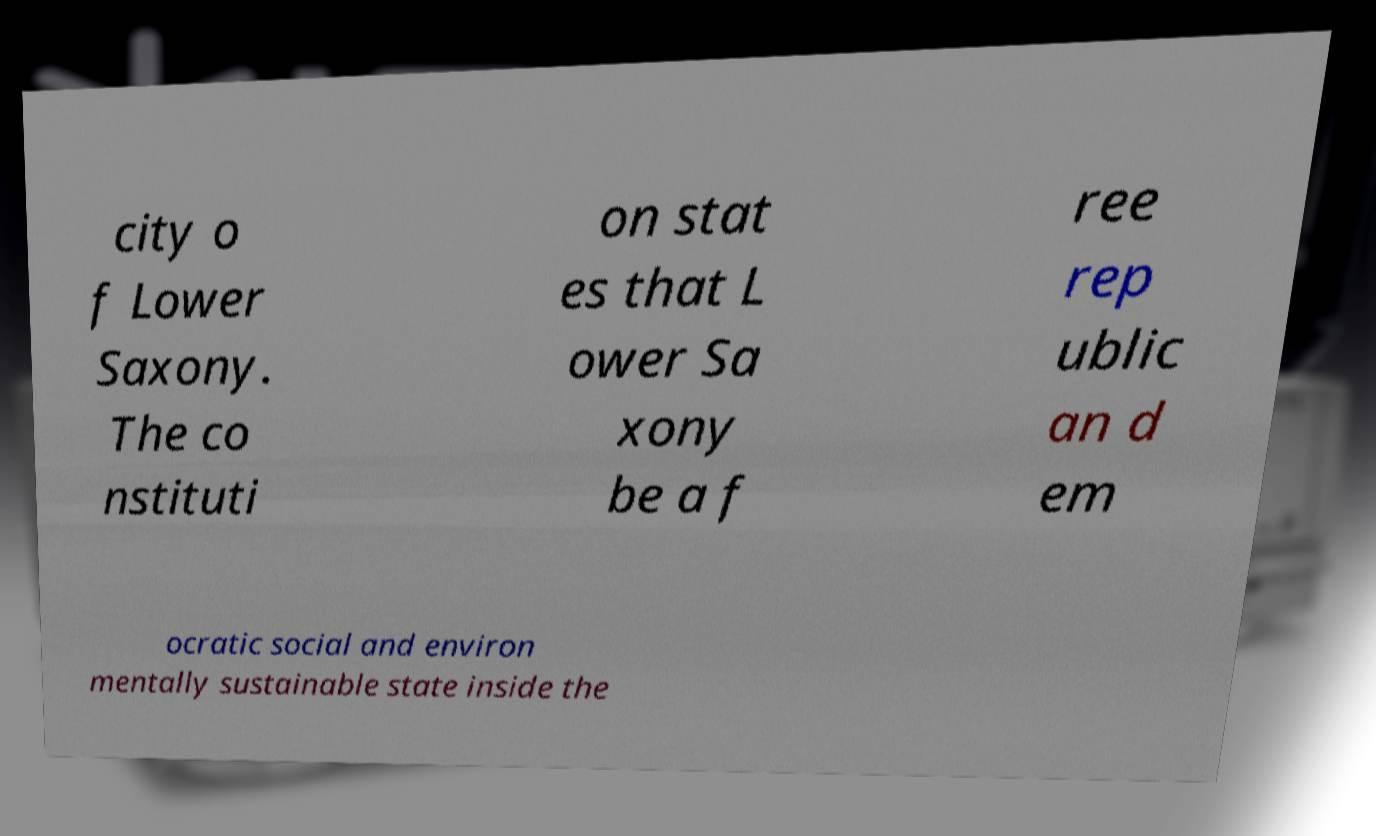Can you accurately transcribe the text from the provided image for me? city o f Lower Saxony. The co nstituti on stat es that L ower Sa xony be a f ree rep ublic an d em ocratic social and environ mentally sustainable state inside the 